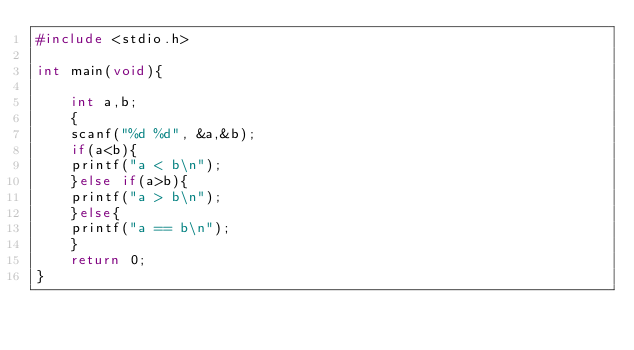<code> <loc_0><loc_0><loc_500><loc_500><_C_>#include <stdio.h>

int main(void){

    int a,b;
    {
    scanf("%d %d", &a,&b);
    if(a<b){
    printf("a < b\n");
    }else if(a>b){
    printf("a > b\n");
    }else{
    printf("a == b\n");
    }
    return 0;
}</code> 